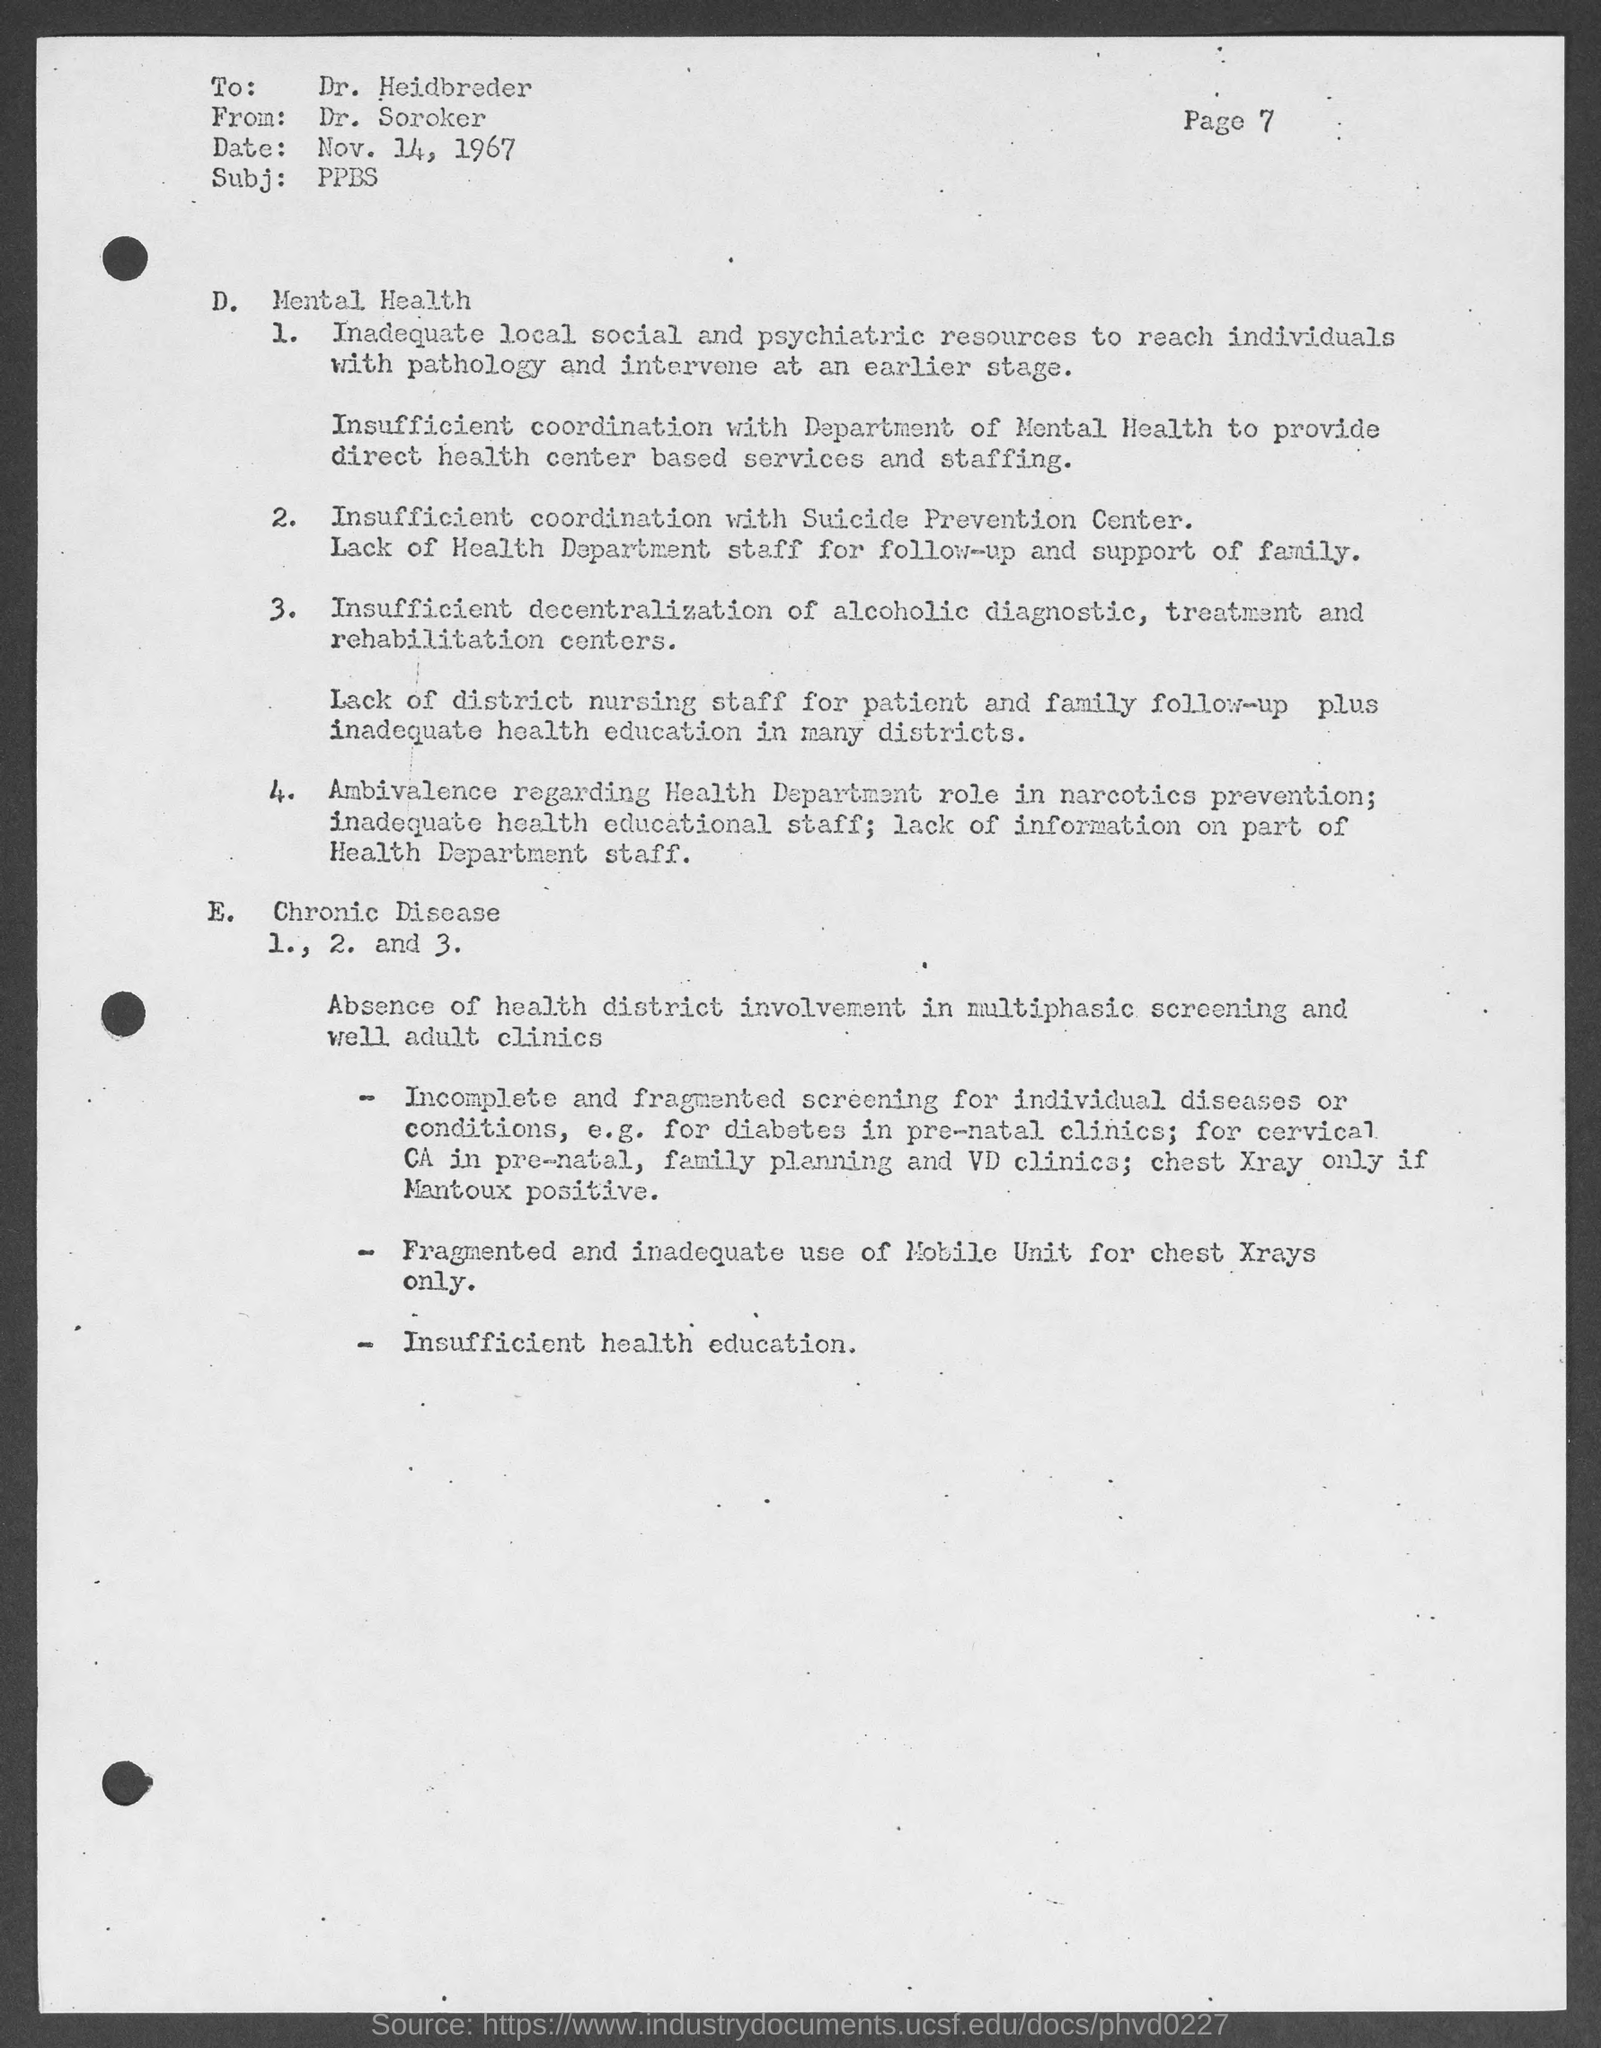What is the date mentioned in this document?
Offer a terse response. Nov. 14, 1967. Who is the sender of this document?
Your response must be concise. Dr. Soroker. What is the Subject mentioned in this document?
Provide a short and direct response. PPBS. Who is the receiver of this document?
Offer a very short reply. Dr. Heidbreder. 